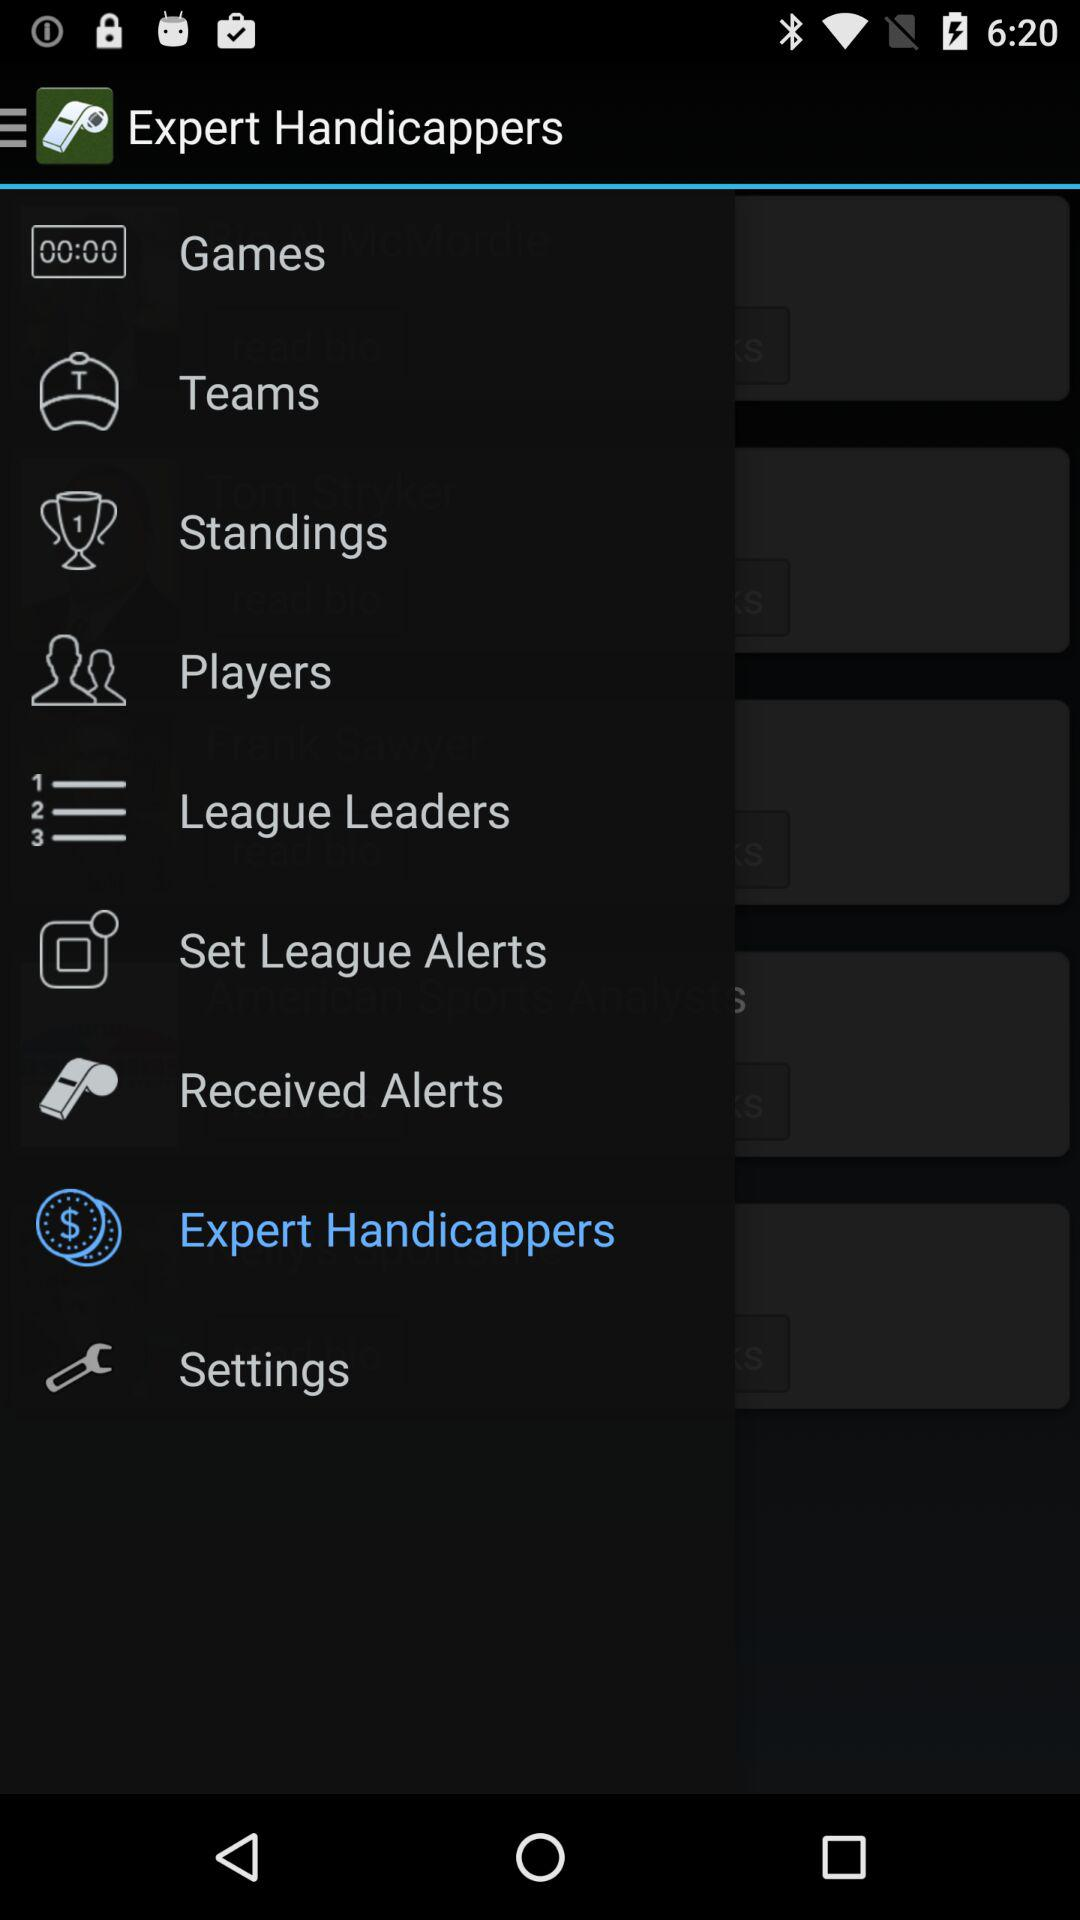What is the application name? The application name is "Sports Alerts - NFL edition". 